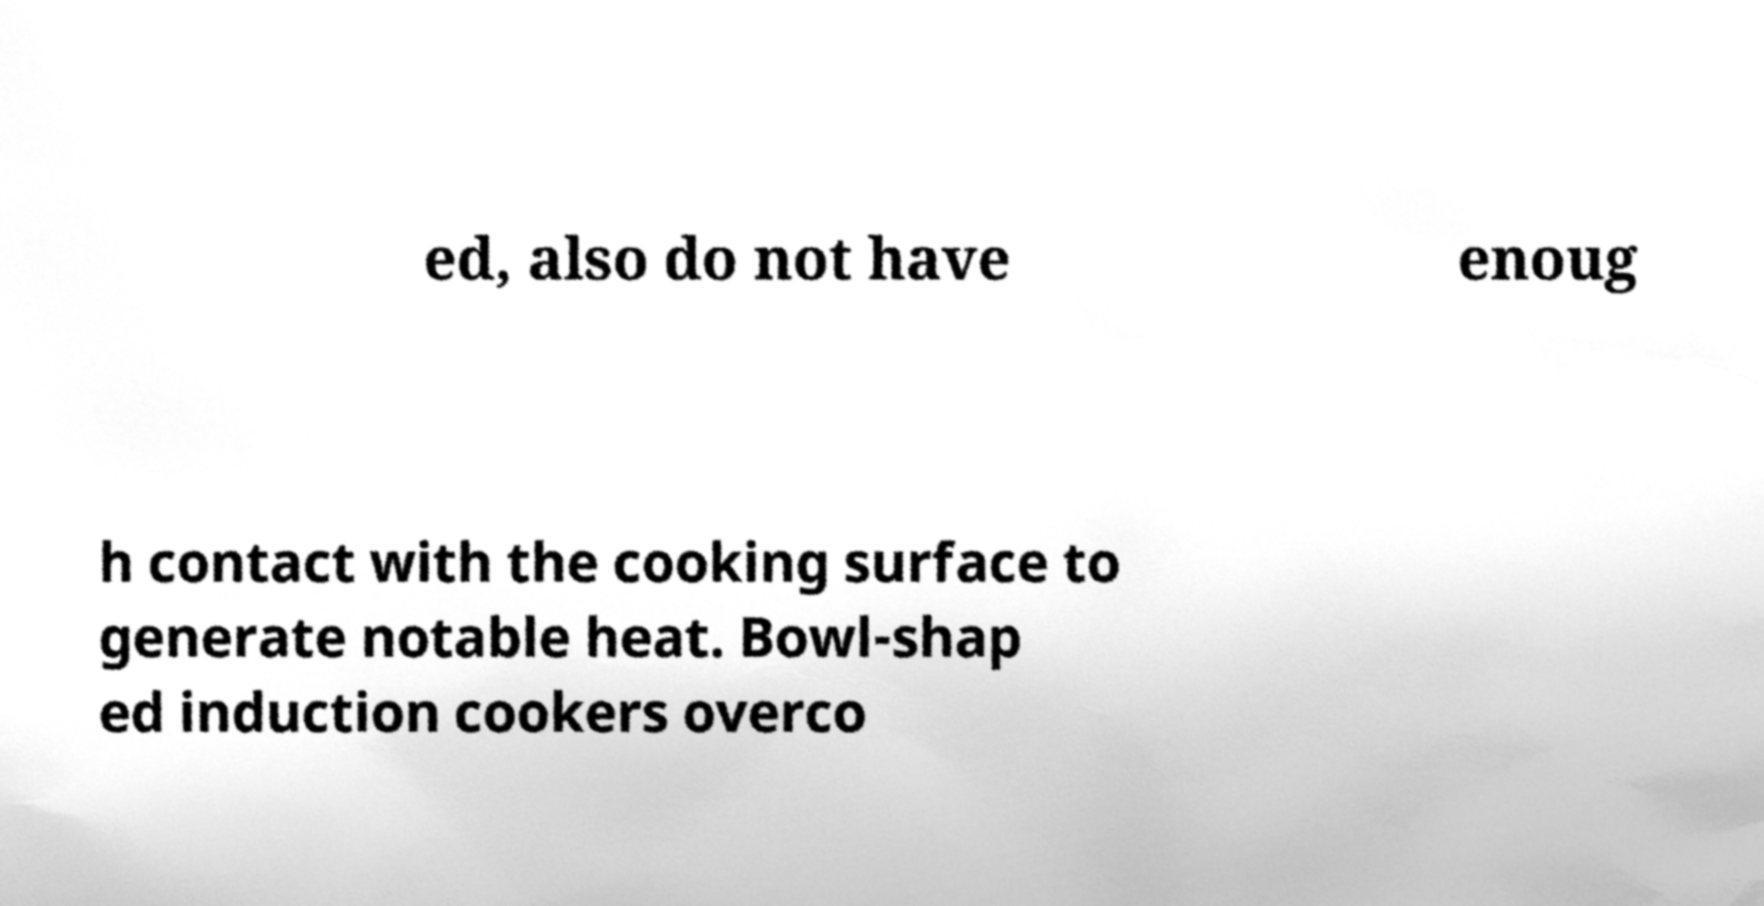Could you assist in decoding the text presented in this image and type it out clearly? ed, also do not have enoug h contact with the cooking surface to generate notable heat. Bowl-shap ed induction cookers overco 